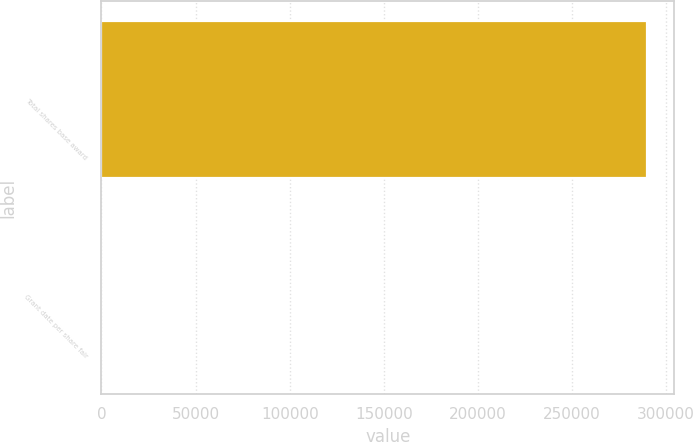Convert chart. <chart><loc_0><loc_0><loc_500><loc_500><bar_chart><fcel>Total shares base award<fcel>Grant date per share fair<nl><fcel>289888<fcel>21.96<nl></chart> 